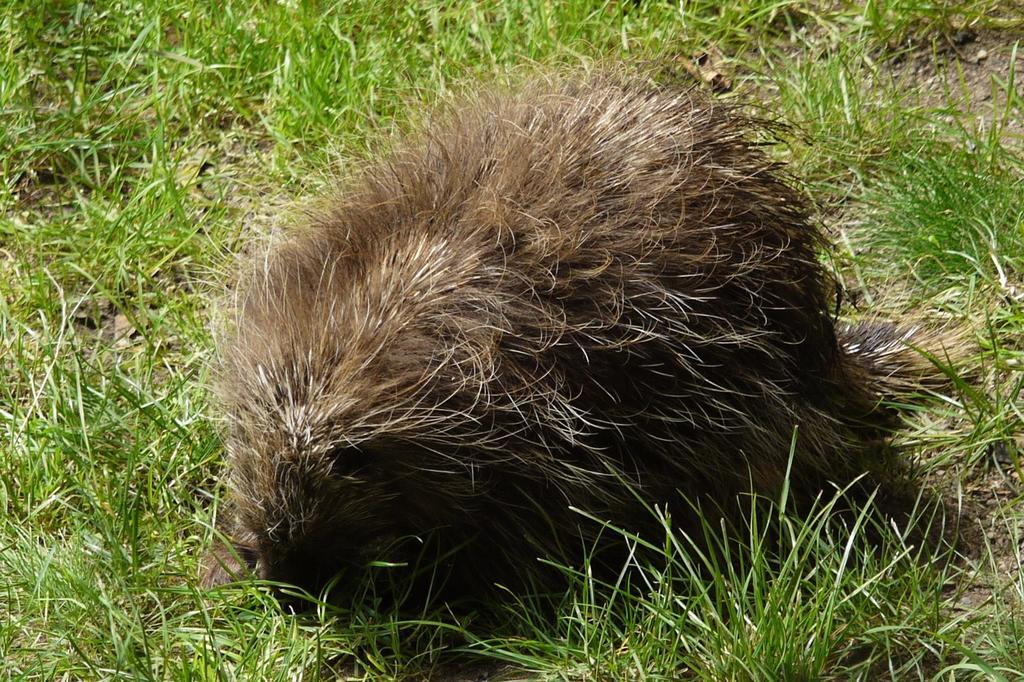What animal is present in the image? There is a porcupine in the image. Where is the porcupine located? The porcupine is on the grass. What type of ice can be seen melting on the railway in the image? There is no ice or railway present in the image; it features a porcupine on the grass. What kind of toy is the porcupine playing with in the image? There is no toy present in the image; the porcupine is simply on the grass. 